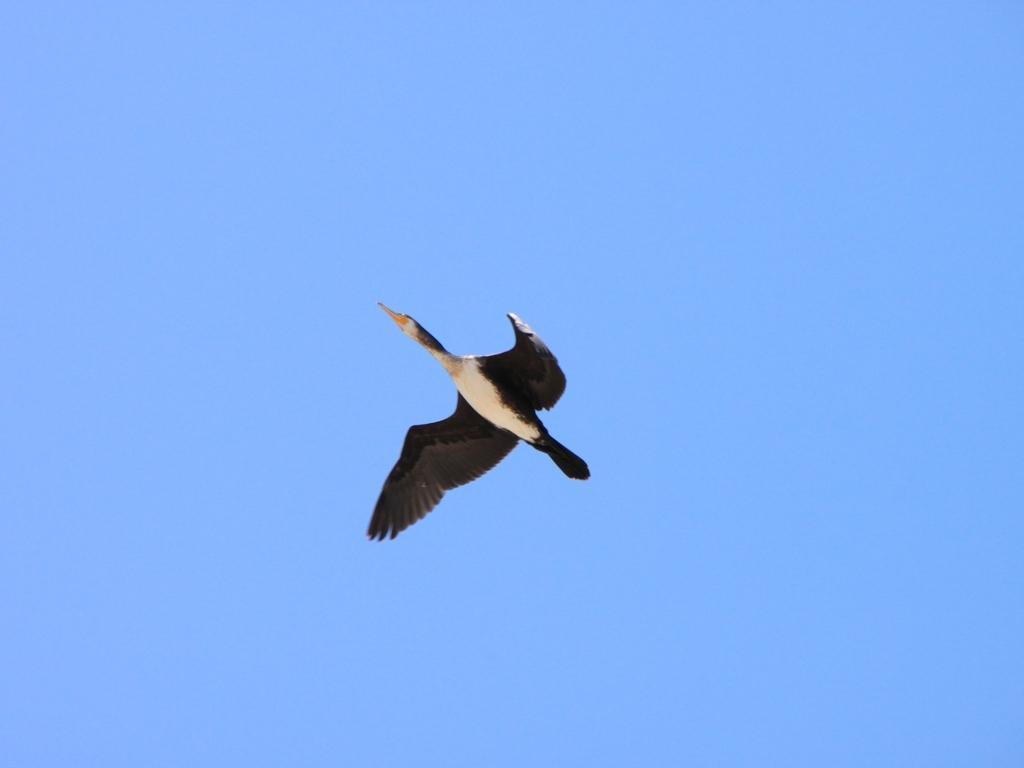How would you summarize this image in a sentence or two? In this image we can see a bird flying in the sky. There is the sky in the image. 